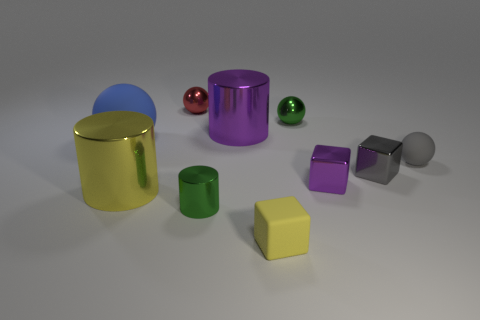Can you infer the texture of the objects in the image? The objects appear to have smooth textures, with some exhibiting a glossy finish that suggests they’re made of materials like plastic or metal. 